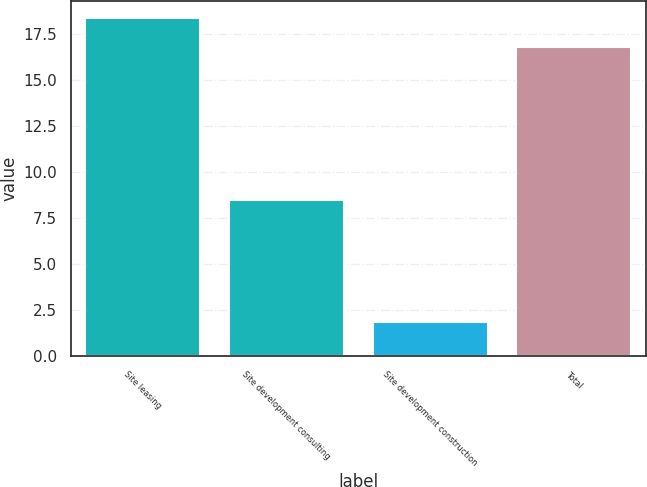<chart> <loc_0><loc_0><loc_500><loc_500><bar_chart><fcel>Site leasing<fcel>Site development consulting<fcel>Site development construction<fcel>Total<nl><fcel>18.4<fcel>8.5<fcel>1.9<fcel>16.8<nl></chart> 